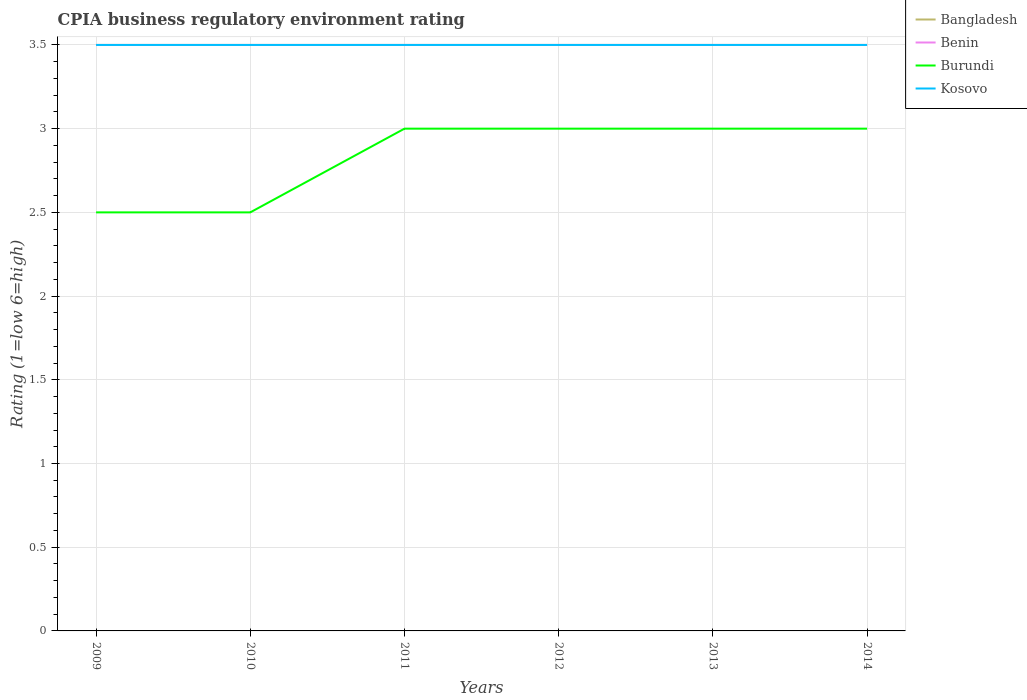How many different coloured lines are there?
Keep it short and to the point. 4. Is the CPIA rating in Kosovo strictly greater than the CPIA rating in Bangladesh over the years?
Offer a very short reply. No. Does the graph contain any zero values?
Ensure brevity in your answer.  No. Where does the legend appear in the graph?
Offer a terse response. Top right. How many legend labels are there?
Provide a short and direct response. 4. How are the legend labels stacked?
Ensure brevity in your answer.  Vertical. What is the title of the graph?
Give a very brief answer. CPIA business regulatory environment rating. What is the label or title of the X-axis?
Ensure brevity in your answer.  Years. What is the label or title of the Y-axis?
Provide a succinct answer. Rating (1=low 6=high). What is the Rating (1=low 6=high) of Burundi in 2009?
Offer a very short reply. 2.5. What is the Rating (1=low 6=high) of Benin in 2010?
Provide a succinct answer. 3.5. What is the Rating (1=low 6=high) of Kosovo in 2010?
Offer a terse response. 3.5. What is the Rating (1=low 6=high) in Benin in 2011?
Give a very brief answer. 3.5. What is the Rating (1=low 6=high) in Burundi in 2011?
Ensure brevity in your answer.  3. What is the Rating (1=low 6=high) in Kosovo in 2011?
Provide a short and direct response. 3.5. What is the Rating (1=low 6=high) in Bangladesh in 2012?
Your answer should be very brief. 3.5. What is the Rating (1=low 6=high) in Benin in 2012?
Your response must be concise. 3.5. What is the Rating (1=low 6=high) of Kosovo in 2012?
Offer a very short reply. 3.5. What is the Rating (1=low 6=high) in Benin in 2013?
Make the answer very short. 3.5. What is the Rating (1=low 6=high) of Bangladesh in 2014?
Make the answer very short. 3.5. What is the Rating (1=low 6=high) in Benin in 2014?
Give a very brief answer. 3.5. What is the Rating (1=low 6=high) in Kosovo in 2014?
Make the answer very short. 3.5. Across all years, what is the maximum Rating (1=low 6=high) of Burundi?
Your response must be concise. 3. Across all years, what is the maximum Rating (1=low 6=high) in Kosovo?
Your answer should be very brief. 3.5. Across all years, what is the minimum Rating (1=low 6=high) of Burundi?
Give a very brief answer. 2.5. Across all years, what is the minimum Rating (1=low 6=high) in Kosovo?
Offer a very short reply. 3.5. What is the total Rating (1=low 6=high) of Burundi in the graph?
Your response must be concise. 17. What is the difference between the Rating (1=low 6=high) of Benin in 2009 and that in 2011?
Ensure brevity in your answer.  0. What is the difference between the Rating (1=low 6=high) of Kosovo in 2009 and that in 2011?
Provide a succinct answer. 0. What is the difference between the Rating (1=low 6=high) of Benin in 2009 and that in 2012?
Provide a succinct answer. 0. What is the difference between the Rating (1=low 6=high) in Burundi in 2009 and that in 2012?
Ensure brevity in your answer.  -0.5. What is the difference between the Rating (1=low 6=high) of Kosovo in 2009 and that in 2012?
Provide a short and direct response. 0. What is the difference between the Rating (1=low 6=high) in Bangladesh in 2009 and that in 2013?
Your response must be concise. 0. What is the difference between the Rating (1=low 6=high) in Kosovo in 2009 and that in 2013?
Your answer should be compact. 0. What is the difference between the Rating (1=low 6=high) of Bangladesh in 2009 and that in 2014?
Keep it short and to the point. 0. What is the difference between the Rating (1=low 6=high) in Burundi in 2009 and that in 2014?
Give a very brief answer. -0.5. What is the difference between the Rating (1=low 6=high) in Benin in 2010 and that in 2011?
Offer a very short reply. 0. What is the difference between the Rating (1=low 6=high) in Burundi in 2010 and that in 2011?
Offer a terse response. -0.5. What is the difference between the Rating (1=low 6=high) in Bangladesh in 2010 and that in 2013?
Provide a succinct answer. 0. What is the difference between the Rating (1=low 6=high) in Bangladesh in 2010 and that in 2014?
Provide a short and direct response. 0. What is the difference between the Rating (1=low 6=high) in Benin in 2010 and that in 2014?
Offer a very short reply. 0. What is the difference between the Rating (1=low 6=high) in Bangladesh in 2011 and that in 2012?
Offer a very short reply. 0. What is the difference between the Rating (1=low 6=high) in Burundi in 2011 and that in 2012?
Your answer should be very brief. 0. What is the difference between the Rating (1=low 6=high) of Benin in 2011 and that in 2013?
Keep it short and to the point. 0. What is the difference between the Rating (1=low 6=high) in Burundi in 2011 and that in 2013?
Your response must be concise. 0. What is the difference between the Rating (1=low 6=high) in Kosovo in 2011 and that in 2013?
Ensure brevity in your answer.  0. What is the difference between the Rating (1=low 6=high) of Bangladesh in 2011 and that in 2014?
Offer a very short reply. 0. What is the difference between the Rating (1=low 6=high) in Benin in 2011 and that in 2014?
Provide a short and direct response. 0. What is the difference between the Rating (1=low 6=high) in Bangladesh in 2012 and that in 2013?
Give a very brief answer. 0. What is the difference between the Rating (1=low 6=high) of Benin in 2012 and that in 2013?
Keep it short and to the point. 0. What is the difference between the Rating (1=low 6=high) in Burundi in 2012 and that in 2013?
Provide a short and direct response. 0. What is the difference between the Rating (1=low 6=high) in Bangladesh in 2012 and that in 2014?
Provide a succinct answer. 0. What is the difference between the Rating (1=low 6=high) in Burundi in 2012 and that in 2014?
Offer a very short reply. 0. What is the difference between the Rating (1=low 6=high) in Kosovo in 2012 and that in 2014?
Provide a short and direct response. 0. What is the difference between the Rating (1=low 6=high) of Bangladesh in 2013 and that in 2014?
Provide a succinct answer. 0. What is the difference between the Rating (1=low 6=high) of Benin in 2013 and that in 2014?
Your answer should be very brief. 0. What is the difference between the Rating (1=low 6=high) of Bangladesh in 2009 and the Rating (1=low 6=high) of Benin in 2010?
Give a very brief answer. 0. What is the difference between the Rating (1=low 6=high) in Bangladesh in 2009 and the Rating (1=low 6=high) in Burundi in 2010?
Offer a very short reply. 1. What is the difference between the Rating (1=low 6=high) in Bangladesh in 2009 and the Rating (1=low 6=high) in Kosovo in 2010?
Make the answer very short. 0. What is the difference between the Rating (1=low 6=high) in Benin in 2009 and the Rating (1=low 6=high) in Burundi in 2010?
Give a very brief answer. 1. What is the difference between the Rating (1=low 6=high) in Benin in 2009 and the Rating (1=low 6=high) in Kosovo in 2010?
Keep it short and to the point. 0. What is the difference between the Rating (1=low 6=high) of Burundi in 2009 and the Rating (1=low 6=high) of Kosovo in 2010?
Ensure brevity in your answer.  -1. What is the difference between the Rating (1=low 6=high) of Bangladesh in 2009 and the Rating (1=low 6=high) of Benin in 2011?
Give a very brief answer. 0. What is the difference between the Rating (1=low 6=high) of Bangladesh in 2009 and the Rating (1=low 6=high) of Burundi in 2011?
Give a very brief answer. 0.5. What is the difference between the Rating (1=low 6=high) in Burundi in 2009 and the Rating (1=low 6=high) in Kosovo in 2011?
Your response must be concise. -1. What is the difference between the Rating (1=low 6=high) in Bangladesh in 2009 and the Rating (1=low 6=high) in Burundi in 2012?
Keep it short and to the point. 0.5. What is the difference between the Rating (1=low 6=high) in Benin in 2009 and the Rating (1=low 6=high) in Burundi in 2012?
Give a very brief answer. 0.5. What is the difference between the Rating (1=low 6=high) of Burundi in 2009 and the Rating (1=low 6=high) of Kosovo in 2012?
Ensure brevity in your answer.  -1. What is the difference between the Rating (1=low 6=high) in Bangladesh in 2009 and the Rating (1=low 6=high) in Benin in 2013?
Your answer should be very brief. 0. What is the difference between the Rating (1=low 6=high) in Bangladesh in 2009 and the Rating (1=low 6=high) in Burundi in 2013?
Keep it short and to the point. 0.5. What is the difference between the Rating (1=low 6=high) of Benin in 2009 and the Rating (1=low 6=high) of Burundi in 2013?
Make the answer very short. 0.5. What is the difference between the Rating (1=low 6=high) of Burundi in 2009 and the Rating (1=low 6=high) of Kosovo in 2013?
Keep it short and to the point. -1. What is the difference between the Rating (1=low 6=high) of Bangladesh in 2009 and the Rating (1=low 6=high) of Benin in 2014?
Keep it short and to the point. 0. What is the difference between the Rating (1=low 6=high) in Bangladesh in 2009 and the Rating (1=low 6=high) in Kosovo in 2014?
Provide a succinct answer. 0. What is the difference between the Rating (1=low 6=high) of Burundi in 2009 and the Rating (1=low 6=high) of Kosovo in 2014?
Your response must be concise. -1. What is the difference between the Rating (1=low 6=high) in Bangladesh in 2010 and the Rating (1=low 6=high) in Benin in 2011?
Offer a terse response. 0. What is the difference between the Rating (1=low 6=high) of Bangladesh in 2010 and the Rating (1=low 6=high) of Kosovo in 2011?
Provide a succinct answer. 0. What is the difference between the Rating (1=low 6=high) in Benin in 2010 and the Rating (1=low 6=high) in Kosovo in 2011?
Provide a succinct answer. 0. What is the difference between the Rating (1=low 6=high) of Burundi in 2010 and the Rating (1=low 6=high) of Kosovo in 2011?
Your answer should be compact. -1. What is the difference between the Rating (1=low 6=high) of Benin in 2010 and the Rating (1=low 6=high) of Burundi in 2012?
Offer a very short reply. 0.5. What is the difference between the Rating (1=low 6=high) of Benin in 2010 and the Rating (1=low 6=high) of Kosovo in 2012?
Ensure brevity in your answer.  0. What is the difference between the Rating (1=low 6=high) in Burundi in 2010 and the Rating (1=low 6=high) in Kosovo in 2012?
Give a very brief answer. -1. What is the difference between the Rating (1=low 6=high) of Bangladesh in 2010 and the Rating (1=low 6=high) of Burundi in 2013?
Offer a very short reply. 0.5. What is the difference between the Rating (1=low 6=high) in Bangladesh in 2010 and the Rating (1=low 6=high) in Kosovo in 2013?
Provide a short and direct response. 0. What is the difference between the Rating (1=low 6=high) of Benin in 2010 and the Rating (1=low 6=high) of Kosovo in 2013?
Provide a short and direct response. 0. What is the difference between the Rating (1=low 6=high) in Bangladesh in 2010 and the Rating (1=low 6=high) in Benin in 2014?
Offer a very short reply. 0. What is the difference between the Rating (1=low 6=high) in Bangladesh in 2010 and the Rating (1=low 6=high) in Burundi in 2014?
Your response must be concise. 0.5. What is the difference between the Rating (1=low 6=high) of Bangladesh in 2010 and the Rating (1=low 6=high) of Kosovo in 2014?
Your response must be concise. 0. What is the difference between the Rating (1=low 6=high) of Bangladesh in 2011 and the Rating (1=low 6=high) of Kosovo in 2012?
Offer a terse response. 0. What is the difference between the Rating (1=low 6=high) of Benin in 2011 and the Rating (1=low 6=high) of Burundi in 2012?
Keep it short and to the point. 0.5. What is the difference between the Rating (1=low 6=high) of Bangladesh in 2011 and the Rating (1=low 6=high) of Benin in 2014?
Your response must be concise. 0. What is the difference between the Rating (1=low 6=high) of Bangladesh in 2011 and the Rating (1=low 6=high) of Kosovo in 2014?
Make the answer very short. 0. What is the difference between the Rating (1=low 6=high) in Benin in 2011 and the Rating (1=low 6=high) in Kosovo in 2014?
Your answer should be very brief. 0. What is the difference between the Rating (1=low 6=high) of Burundi in 2011 and the Rating (1=low 6=high) of Kosovo in 2014?
Offer a terse response. -0.5. What is the difference between the Rating (1=low 6=high) of Bangladesh in 2012 and the Rating (1=low 6=high) of Benin in 2013?
Ensure brevity in your answer.  0. What is the difference between the Rating (1=low 6=high) of Bangladesh in 2012 and the Rating (1=low 6=high) of Burundi in 2013?
Give a very brief answer. 0.5. What is the difference between the Rating (1=low 6=high) of Bangladesh in 2012 and the Rating (1=low 6=high) of Kosovo in 2013?
Keep it short and to the point. 0. What is the difference between the Rating (1=low 6=high) in Benin in 2012 and the Rating (1=low 6=high) in Kosovo in 2013?
Provide a succinct answer. 0. What is the difference between the Rating (1=low 6=high) in Bangladesh in 2012 and the Rating (1=low 6=high) in Benin in 2014?
Provide a short and direct response. 0. What is the difference between the Rating (1=low 6=high) in Bangladesh in 2012 and the Rating (1=low 6=high) in Burundi in 2014?
Offer a very short reply. 0.5. What is the difference between the Rating (1=low 6=high) of Benin in 2012 and the Rating (1=low 6=high) of Burundi in 2014?
Provide a short and direct response. 0.5. What is the difference between the Rating (1=low 6=high) of Burundi in 2012 and the Rating (1=low 6=high) of Kosovo in 2014?
Offer a very short reply. -0.5. What is the difference between the Rating (1=low 6=high) of Burundi in 2013 and the Rating (1=low 6=high) of Kosovo in 2014?
Make the answer very short. -0.5. What is the average Rating (1=low 6=high) in Bangladesh per year?
Offer a terse response. 3.5. What is the average Rating (1=low 6=high) in Benin per year?
Keep it short and to the point. 3.5. What is the average Rating (1=low 6=high) in Burundi per year?
Provide a succinct answer. 2.83. What is the average Rating (1=low 6=high) in Kosovo per year?
Provide a short and direct response. 3.5. In the year 2009, what is the difference between the Rating (1=low 6=high) of Bangladesh and Rating (1=low 6=high) of Burundi?
Provide a short and direct response. 1. In the year 2009, what is the difference between the Rating (1=low 6=high) in Bangladesh and Rating (1=low 6=high) in Kosovo?
Offer a very short reply. 0. In the year 2009, what is the difference between the Rating (1=low 6=high) in Benin and Rating (1=low 6=high) in Kosovo?
Make the answer very short. 0. In the year 2010, what is the difference between the Rating (1=low 6=high) of Bangladesh and Rating (1=low 6=high) of Benin?
Provide a short and direct response. 0. In the year 2011, what is the difference between the Rating (1=low 6=high) in Bangladesh and Rating (1=low 6=high) in Kosovo?
Make the answer very short. 0. In the year 2011, what is the difference between the Rating (1=low 6=high) of Benin and Rating (1=low 6=high) of Burundi?
Ensure brevity in your answer.  0.5. In the year 2012, what is the difference between the Rating (1=low 6=high) in Bangladesh and Rating (1=low 6=high) in Benin?
Provide a succinct answer. 0. In the year 2012, what is the difference between the Rating (1=low 6=high) in Bangladesh and Rating (1=low 6=high) in Kosovo?
Offer a very short reply. 0. In the year 2012, what is the difference between the Rating (1=low 6=high) of Benin and Rating (1=low 6=high) of Burundi?
Give a very brief answer. 0.5. In the year 2013, what is the difference between the Rating (1=low 6=high) of Bangladesh and Rating (1=low 6=high) of Benin?
Give a very brief answer. 0. In the year 2013, what is the difference between the Rating (1=low 6=high) in Bangladesh and Rating (1=low 6=high) in Burundi?
Provide a short and direct response. 0.5. In the year 2013, what is the difference between the Rating (1=low 6=high) of Bangladesh and Rating (1=low 6=high) of Kosovo?
Your answer should be compact. 0. In the year 2013, what is the difference between the Rating (1=low 6=high) of Benin and Rating (1=low 6=high) of Burundi?
Make the answer very short. 0.5. In the year 2013, what is the difference between the Rating (1=low 6=high) in Benin and Rating (1=low 6=high) in Kosovo?
Your answer should be very brief. 0. In the year 2014, what is the difference between the Rating (1=low 6=high) in Bangladesh and Rating (1=low 6=high) in Benin?
Ensure brevity in your answer.  0. In the year 2014, what is the difference between the Rating (1=low 6=high) in Bangladesh and Rating (1=low 6=high) in Burundi?
Your answer should be very brief. 0.5. In the year 2014, what is the difference between the Rating (1=low 6=high) in Bangladesh and Rating (1=low 6=high) in Kosovo?
Keep it short and to the point. 0. In the year 2014, what is the difference between the Rating (1=low 6=high) in Burundi and Rating (1=low 6=high) in Kosovo?
Keep it short and to the point. -0.5. What is the ratio of the Rating (1=low 6=high) in Burundi in 2009 to that in 2010?
Provide a short and direct response. 1. What is the ratio of the Rating (1=low 6=high) of Kosovo in 2009 to that in 2010?
Keep it short and to the point. 1. What is the ratio of the Rating (1=low 6=high) of Benin in 2009 to that in 2011?
Your answer should be compact. 1. What is the ratio of the Rating (1=low 6=high) of Burundi in 2009 to that in 2011?
Offer a very short reply. 0.83. What is the ratio of the Rating (1=low 6=high) of Bangladesh in 2009 to that in 2012?
Your response must be concise. 1. What is the ratio of the Rating (1=low 6=high) of Benin in 2009 to that in 2012?
Provide a succinct answer. 1. What is the ratio of the Rating (1=low 6=high) of Bangladesh in 2009 to that in 2013?
Make the answer very short. 1. What is the ratio of the Rating (1=low 6=high) in Benin in 2009 to that in 2013?
Give a very brief answer. 1. What is the ratio of the Rating (1=low 6=high) in Kosovo in 2009 to that in 2013?
Provide a succinct answer. 1. What is the ratio of the Rating (1=low 6=high) of Bangladesh in 2009 to that in 2014?
Your response must be concise. 1. What is the ratio of the Rating (1=low 6=high) in Benin in 2009 to that in 2014?
Your answer should be compact. 1. What is the ratio of the Rating (1=low 6=high) in Burundi in 2009 to that in 2014?
Make the answer very short. 0.83. What is the ratio of the Rating (1=low 6=high) of Kosovo in 2009 to that in 2014?
Provide a short and direct response. 1. What is the ratio of the Rating (1=low 6=high) in Bangladesh in 2010 to that in 2011?
Give a very brief answer. 1. What is the ratio of the Rating (1=low 6=high) of Bangladesh in 2010 to that in 2012?
Give a very brief answer. 1. What is the ratio of the Rating (1=low 6=high) in Burundi in 2010 to that in 2012?
Provide a succinct answer. 0.83. What is the ratio of the Rating (1=low 6=high) of Bangladesh in 2010 to that in 2013?
Your answer should be very brief. 1. What is the ratio of the Rating (1=low 6=high) of Benin in 2010 to that in 2013?
Provide a short and direct response. 1. What is the ratio of the Rating (1=low 6=high) of Burundi in 2010 to that in 2013?
Provide a succinct answer. 0.83. What is the ratio of the Rating (1=low 6=high) of Kosovo in 2010 to that in 2013?
Keep it short and to the point. 1. What is the ratio of the Rating (1=low 6=high) in Bangladesh in 2010 to that in 2014?
Provide a short and direct response. 1. What is the ratio of the Rating (1=low 6=high) of Benin in 2011 to that in 2012?
Give a very brief answer. 1. What is the ratio of the Rating (1=low 6=high) of Burundi in 2011 to that in 2012?
Provide a short and direct response. 1. What is the ratio of the Rating (1=low 6=high) of Bangladesh in 2011 to that in 2013?
Provide a short and direct response. 1. What is the ratio of the Rating (1=low 6=high) in Benin in 2011 to that in 2013?
Provide a succinct answer. 1. What is the ratio of the Rating (1=low 6=high) in Bangladesh in 2011 to that in 2014?
Ensure brevity in your answer.  1. What is the ratio of the Rating (1=low 6=high) of Burundi in 2011 to that in 2014?
Provide a succinct answer. 1. What is the ratio of the Rating (1=low 6=high) in Benin in 2012 to that in 2013?
Offer a very short reply. 1. What is the ratio of the Rating (1=low 6=high) of Burundi in 2012 to that in 2013?
Provide a short and direct response. 1. What is the ratio of the Rating (1=low 6=high) of Bangladesh in 2012 to that in 2014?
Offer a terse response. 1. What is the ratio of the Rating (1=low 6=high) in Benin in 2012 to that in 2014?
Offer a terse response. 1. What is the ratio of the Rating (1=low 6=high) in Bangladesh in 2013 to that in 2014?
Offer a very short reply. 1. What is the ratio of the Rating (1=low 6=high) of Benin in 2013 to that in 2014?
Make the answer very short. 1. What is the difference between the highest and the second highest Rating (1=low 6=high) of Kosovo?
Keep it short and to the point. 0. What is the difference between the highest and the lowest Rating (1=low 6=high) in Kosovo?
Keep it short and to the point. 0. 